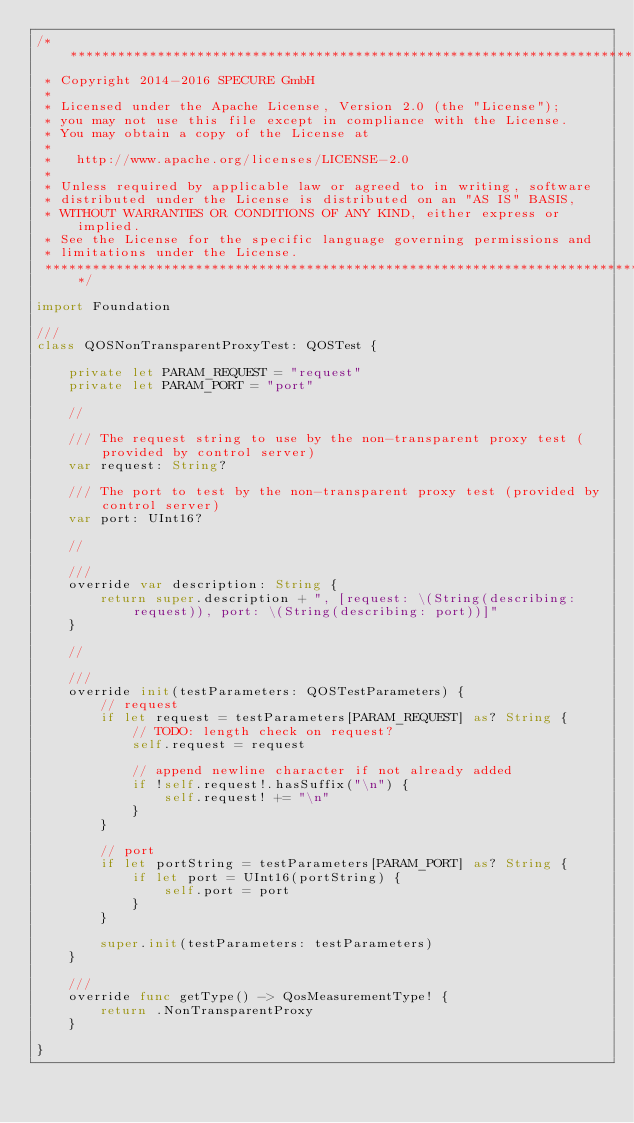<code> <loc_0><loc_0><loc_500><loc_500><_Swift_>/*****************************************************************************************************
 * Copyright 2014-2016 SPECURE GmbH
 *
 * Licensed under the Apache License, Version 2.0 (the "License");
 * you may not use this file except in compliance with the License.
 * You may obtain a copy of the License at
 *
 *   http://www.apache.org/licenses/LICENSE-2.0
 *
 * Unless required by applicable law or agreed to in writing, software
 * distributed under the License is distributed on an "AS IS" BASIS,
 * WITHOUT WARRANTIES OR CONDITIONS OF ANY KIND, either express or implied.
 * See the License for the specific language governing permissions and
 * limitations under the License.
 *****************************************************************************************************/

import Foundation

///
class QOSNonTransparentProxyTest: QOSTest {

    private let PARAM_REQUEST = "request"
    private let PARAM_PORT = "port"

    //

    /// The request string to use by the non-transparent proxy test (provided by control server)
    var request: String?

    /// The port to test by the non-transparent proxy test (provided by control server)
    var port: UInt16?

    //

    ///
    override var description: String {
        return super.description + ", [request: \(String(describing: request)), port: \(String(describing: port))]"
    }

    //

    ///
    override init(testParameters: QOSTestParameters) {
        // request
        if let request = testParameters[PARAM_REQUEST] as? String {
            // TODO: length check on request?
            self.request = request

            // append newline character if not already added
            if !self.request!.hasSuffix("\n") {
                self.request! += "\n"
            }
        }

        // port
        if let portString = testParameters[PARAM_PORT] as? String {
            if let port = UInt16(portString) {
                self.port = port
            }
        }

        super.init(testParameters: testParameters)
    }

    ///
    override func getType() -> QosMeasurementType! {
        return .NonTransparentProxy
    }

}
</code> 